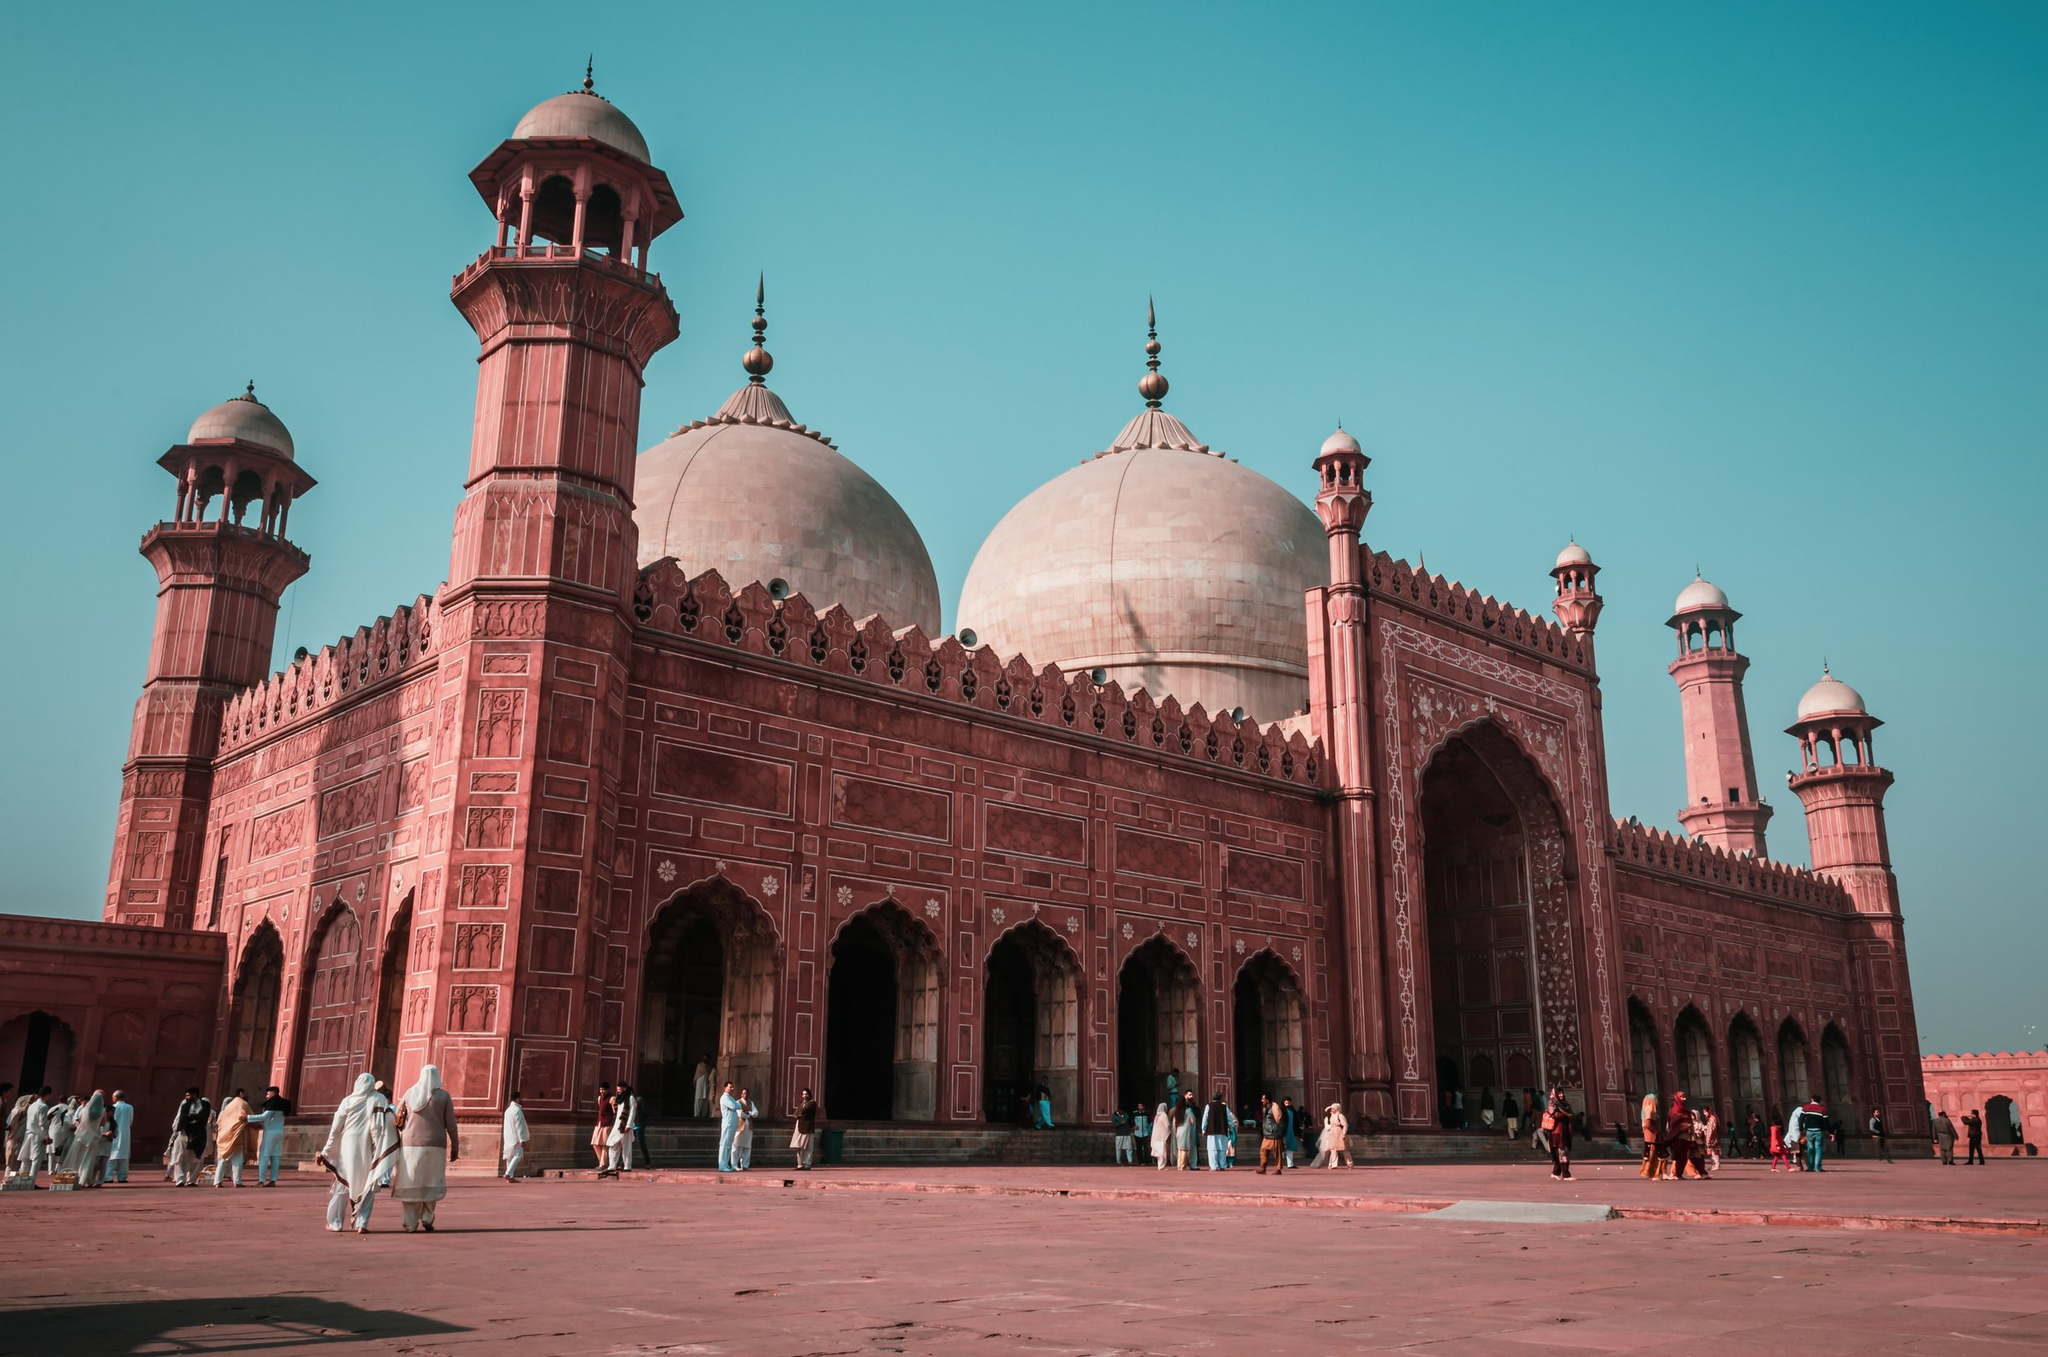What are the primary architectural features of this mosque? The Badshahi Mosque is renowned for its extensive use of red sandstone and white marble. Key architectural features include large domes, tall minarets, and intricate carvings. The domes are made of white marble, which contrasts beautifully with the red sandstone walls. The mosque also has a large courtyard where worshippers gather, and it is adorned with mosaic work and detailed frescoes. It’s a quintessential example of Mughal architecture with its grandiosity and attention to intricate details. 